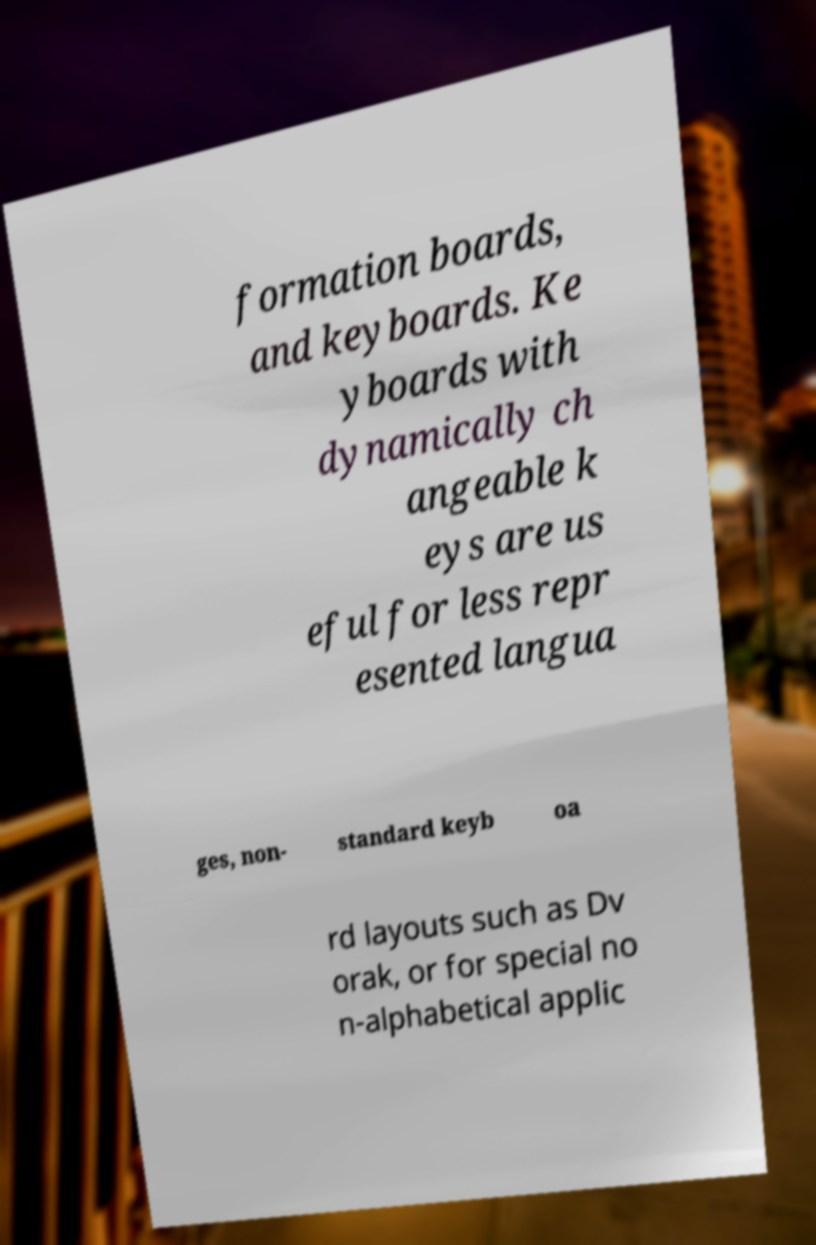Could you assist in decoding the text presented in this image and type it out clearly? formation boards, and keyboards. Ke yboards with dynamically ch angeable k eys are us eful for less repr esented langua ges, non- standard keyb oa rd layouts such as Dv orak, or for special no n-alphabetical applic 